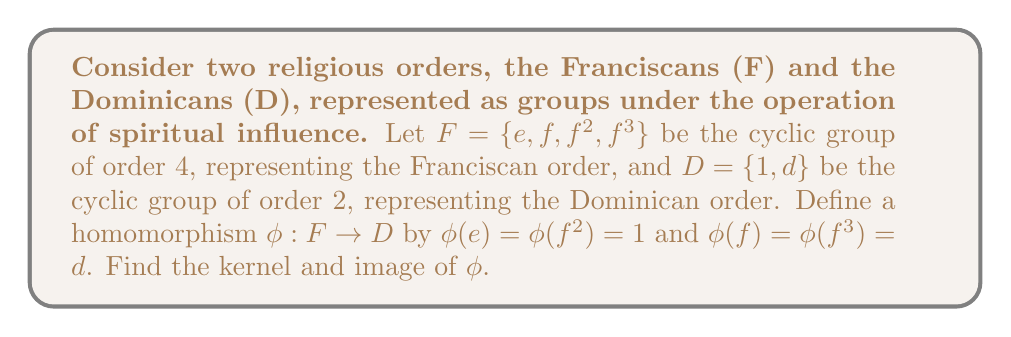Show me your answer to this math problem. To find the kernel and image of the homomorphism $\phi$, we need to understand the concept of homomorphisms in group theory and apply it to our religious context.

1. Kernel of $\phi$:
The kernel of a homomorphism is the set of elements in the domain that map to the identity element in the codomain. In this case, we need to find all elements of F that map to the identity element of D, which is 1.

$\text{Ker}(\phi) = \{x \in F : \phi(x) = 1\}$

From the given definition of $\phi$, we can see that:
$\phi(e) = 1$
$\phi(f^2) = 1$

Therefore, $\text{Ker}(\phi) = \{e, f^2\}$

2. Image of $\phi$:
The image of a homomorphism is the set of all elements in the codomain that are mapped to by at least one element in the domain.

$\text{Im}(\phi) = \{\phi(x) : x \in F\}$

From the definition of $\phi$, we can see that:
$\phi(e) = 1$
$\phi(f) = d$
$\phi(f^2) = 1$
$\phi(f^3) = d$

Therefore, $\text{Im}(\phi) = \{1, d\}$

Interpreting this result in our religious context:
- The kernel represents the elements of the Franciscan order that have no distinct influence on the Dominican order (they map to the identity).
- The image represents all possible influences the Franciscan order can have on the Dominican order through this spiritual mapping.
Answer: Kernel: $\text{Ker}(\phi) = \{e, f^2\}$
Image: $\text{Im}(\phi) = \{1, d\}$ 